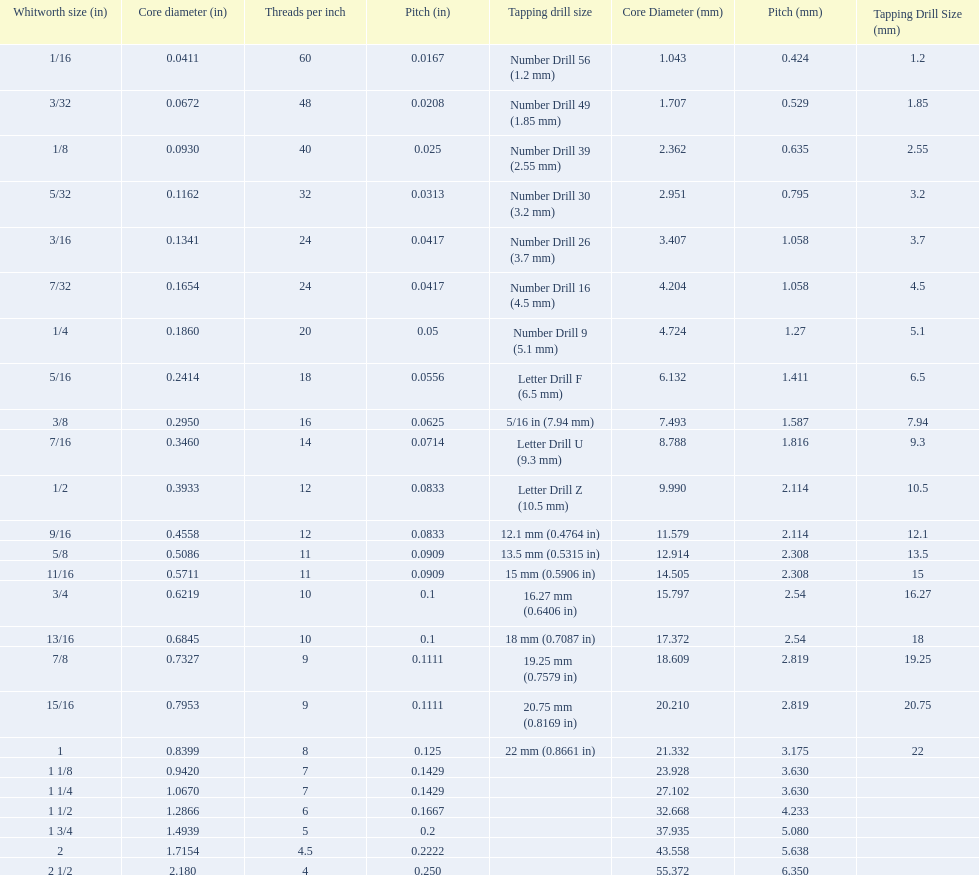What is the core diameter of the last whitworth thread size? 2.180. 